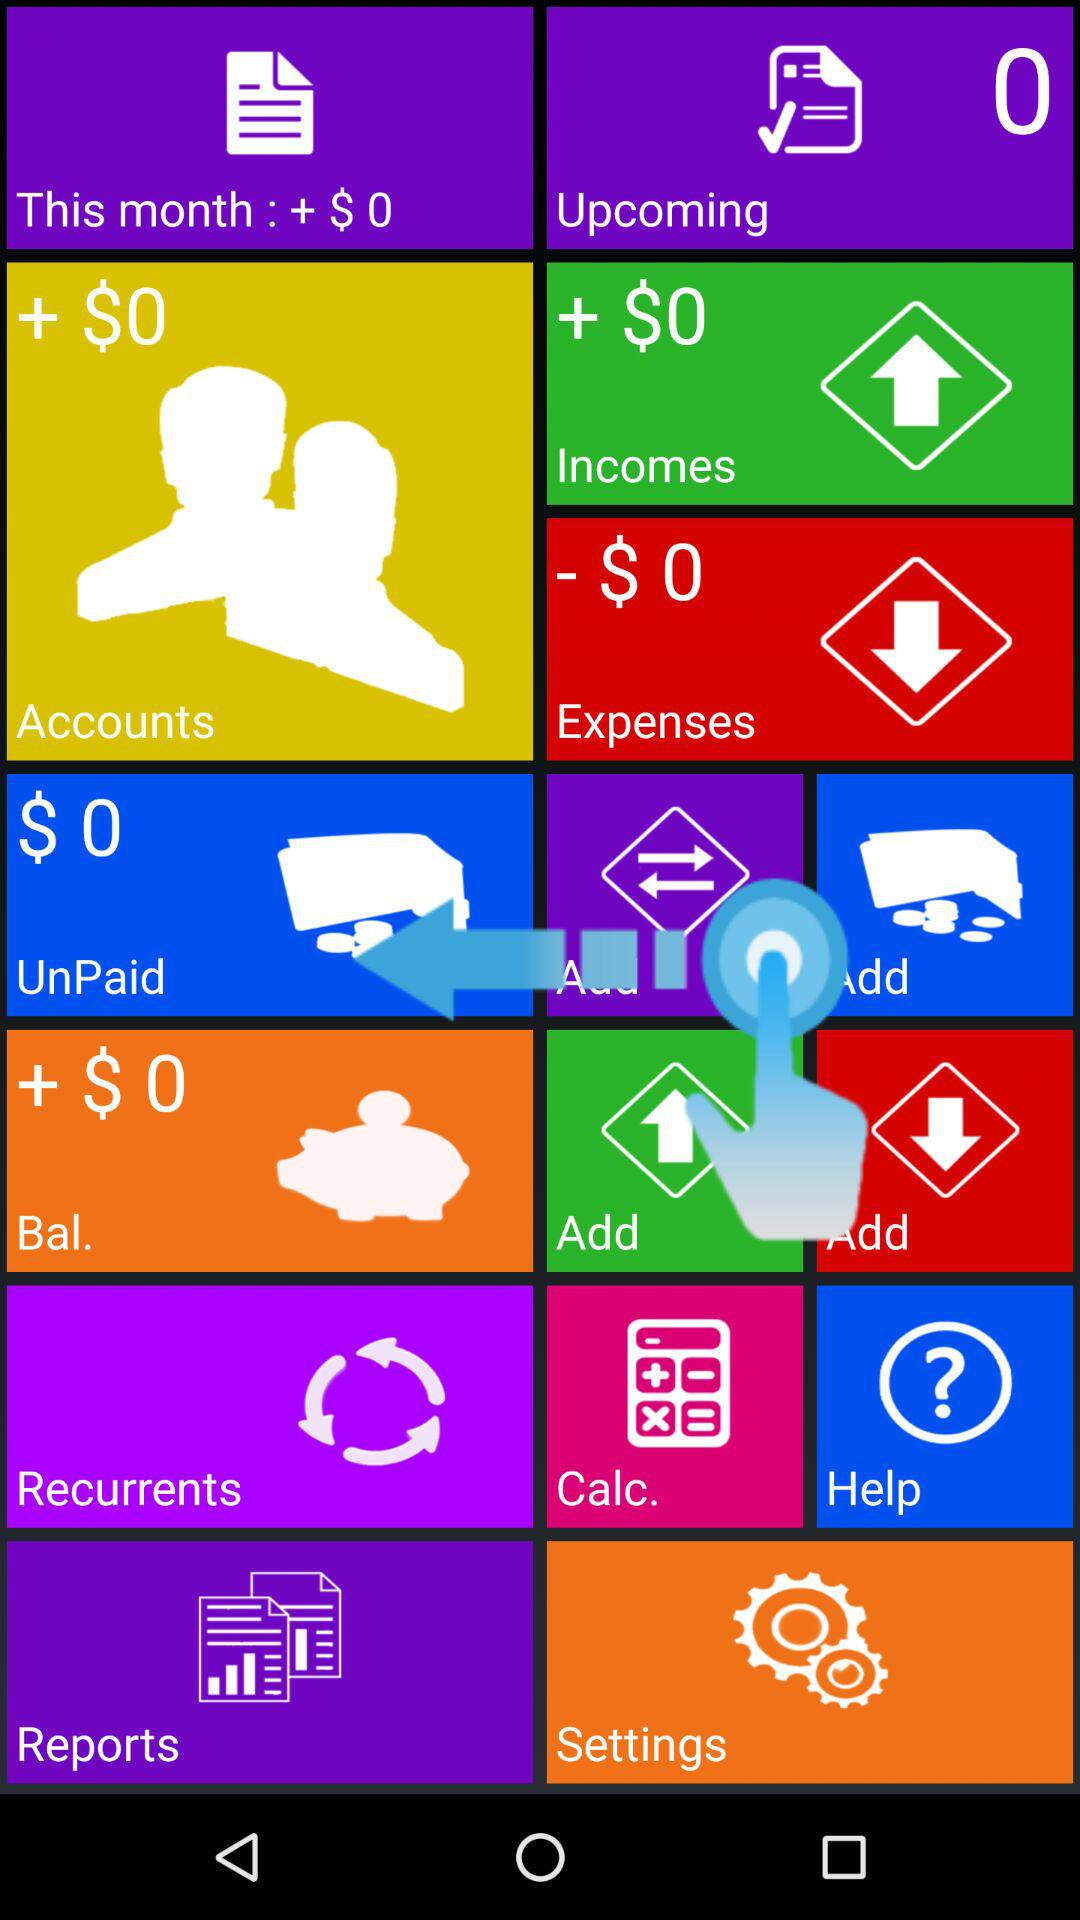How much income is showing? The income shown is + $0. 